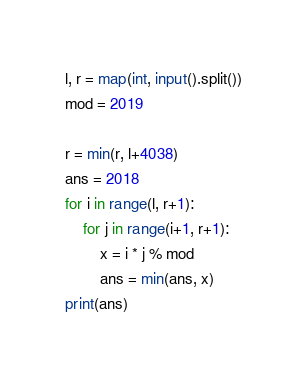Convert code to text. <code><loc_0><loc_0><loc_500><loc_500><_Python_>l, r = map(int, input().split())
mod = 2019

r = min(r, l+4038)
ans = 2018
for i in range(l, r+1):
    for j in range(i+1, r+1):
        x = i * j % mod
        ans = min(ans, x)
print(ans)
</code> 